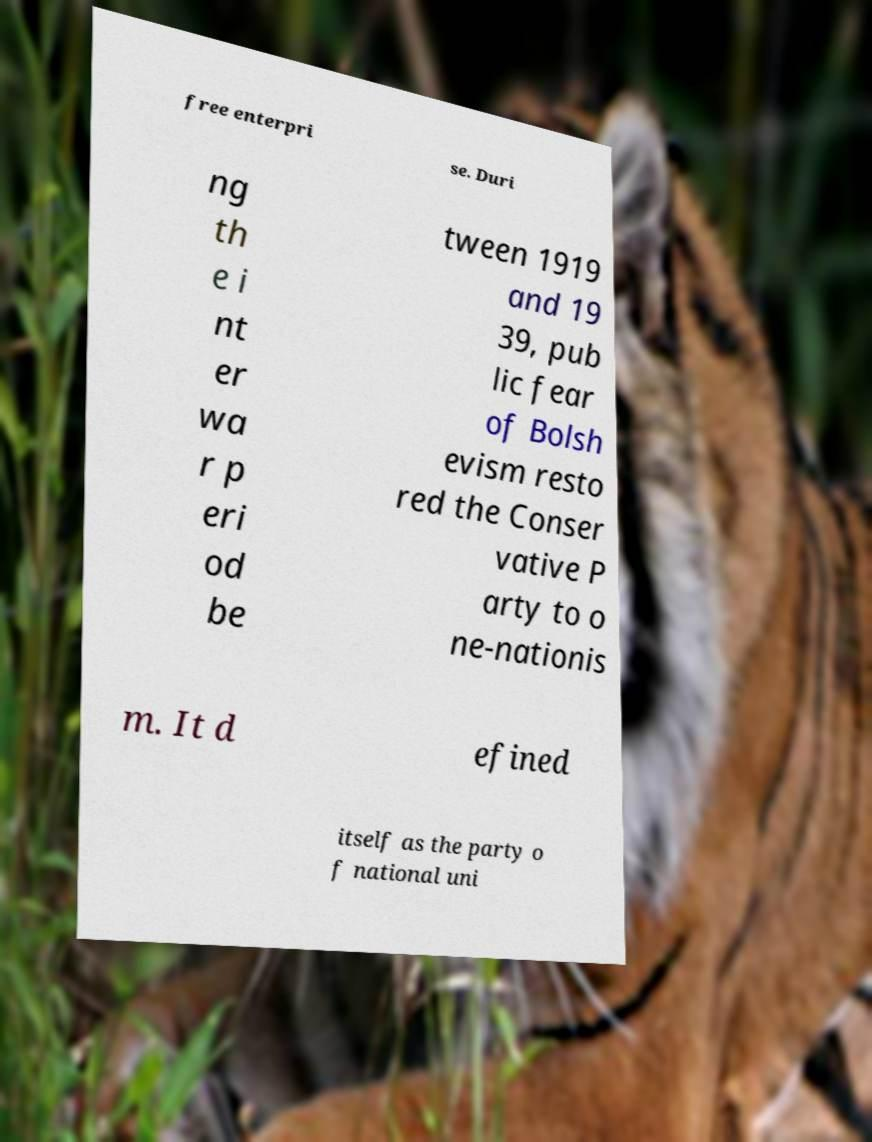There's text embedded in this image that I need extracted. Can you transcribe it verbatim? free enterpri se. Duri ng th e i nt er wa r p eri od be tween 1919 and 19 39, pub lic fear of Bolsh evism resto red the Conser vative P arty to o ne-nationis m. It d efined itself as the party o f national uni 